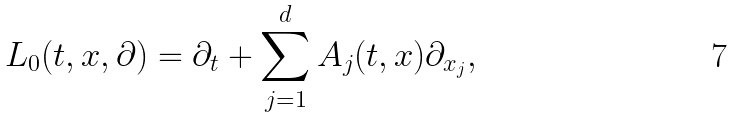<formula> <loc_0><loc_0><loc_500><loc_500>L _ { 0 } ( t , x , \partial ) = \partial _ { t } + \sum _ { j = 1 } ^ { d } A _ { j } ( t , x ) \partial _ { x _ { j } } ,</formula> 